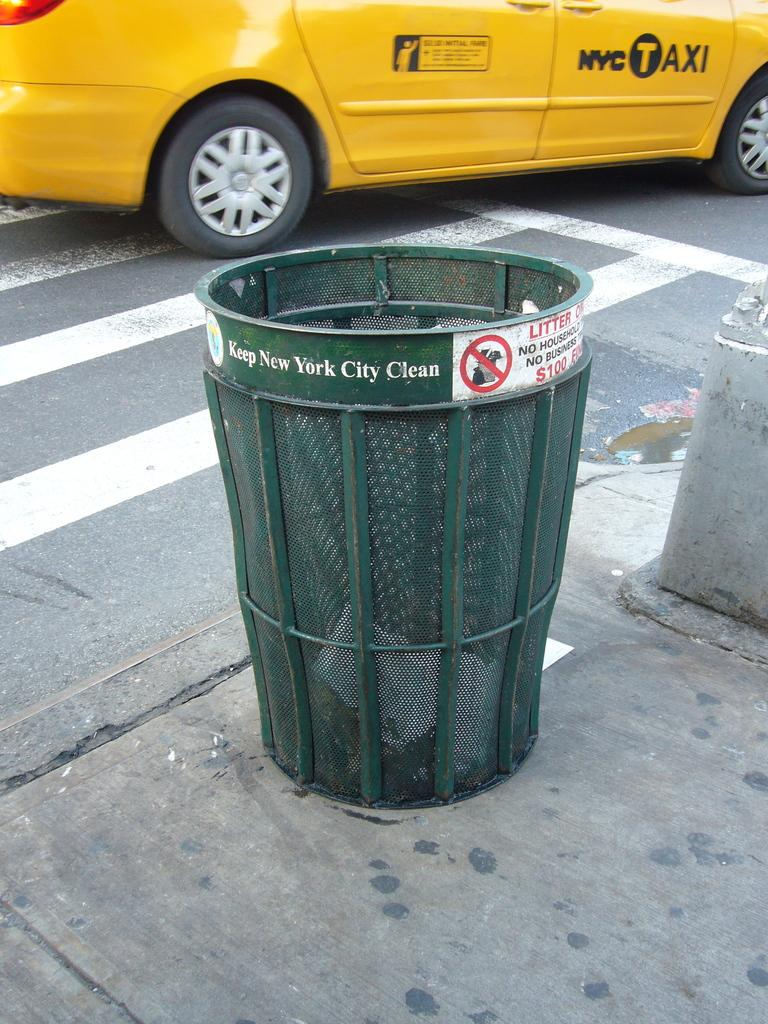<image>
Share a concise interpretation of the image provided. A green trash can reads, "Keep New York City Clean around the rim. 